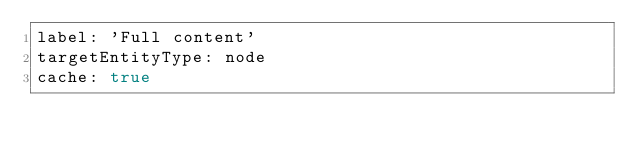Convert code to text. <code><loc_0><loc_0><loc_500><loc_500><_YAML_>label: 'Full content'
targetEntityType: node
cache: true
</code> 